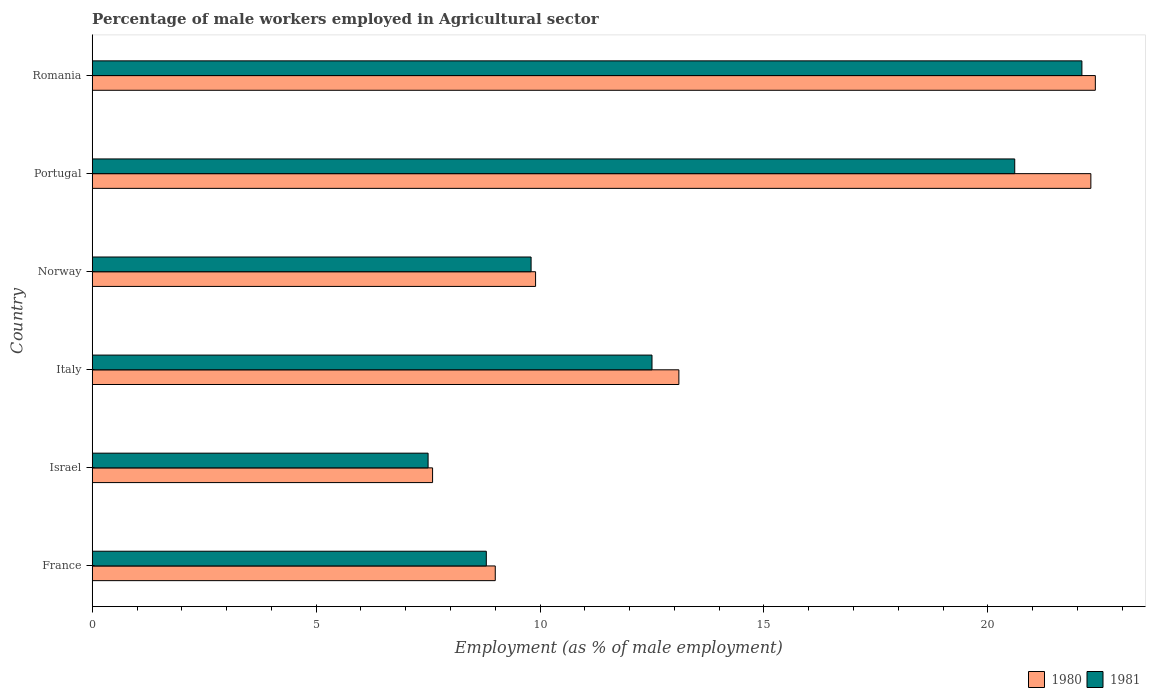In how many cases, is the number of bars for a given country not equal to the number of legend labels?
Make the answer very short. 0. What is the percentage of male workers employed in Agricultural sector in 1980 in Israel?
Provide a succinct answer. 7.6. Across all countries, what is the maximum percentage of male workers employed in Agricultural sector in 1981?
Give a very brief answer. 22.1. Across all countries, what is the minimum percentage of male workers employed in Agricultural sector in 1981?
Make the answer very short. 7.5. In which country was the percentage of male workers employed in Agricultural sector in 1981 maximum?
Provide a short and direct response. Romania. In which country was the percentage of male workers employed in Agricultural sector in 1981 minimum?
Keep it short and to the point. Israel. What is the total percentage of male workers employed in Agricultural sector in 1980 in the graph?
Provide a short and direct response. 84.3. What is the difference between the percentage of male workers employed in Agricultural sector in 1981 in Israel and that in Romania?
Provide a succinct answer. -14.6. What is the difference between the percentage of male workers employed in Agricultural sector in 1981 in Portugal and the percentage of male workers employed in Agricultural sector in 1980 in Romania?
Your answer should be very brief. -1.8. What is the average percentage of male workers employed in Agricultural sector in 1980 per country?
Your response must be concise. 14.05. What is the difference between the percentage of male workers employed in Agricultural sector in 1981 and percentage of male workers employed in Agricultural sector in 1980 in France?
Give a very brief answer. -0.2. In how many countries, is the percentage of male workers employed in Agricultural sector in 1980 greater than 12 %?
Ensure brevity in your answer.  3. What is the ratio of the percentage of male workers employed in Agricultural sector in 1981 in Italy to that in Romania?
Make the answer very short. 0.57. Is the difference between the percentage of male workers employed in Agricultural sector in 1981 in Portugal and Romania greater than the difference between the percentage of male workers employed in Agricultural sector in 1980 in Portugal and Romania?
Provide a short and direct response. No. What is the difference between the highest and the second highest percentage of male workers employed in Agricultural sector in 1981?
Keep it short and to the point. 1.5. What is the difference between the highest and the lowest percentage of male workers employed in Agricultural sector in 1980?
Make the answer very short. 14.8. In how many countries, is the percentage of male workers employed in Agricultural sector in 1980 greater than the average percentage of male workers employed in Agricultural sector in 1980 taken over all countries?
Ensure brevity in your answer.  2. Is the sum of the percentage of male workers employed in Agricultural sector in 1981 in Israel and Norway greater than the maximum percentage of male workers employed in Agricultural sector in 1980 across all countries?
Make the answer very short. No. What does the 1st bar from the top in Portugal represents?
Ensure brevity in your answer.  1981. What does the 2nd bar from the bottom in Romania represents?
Offer a very short reply. 1981. Are the values on the major ticks of X-axis written in scientific E-notation?
Ensure brevity in your answer.  No. What is the title of the graph?
Offer a terse response. Percentage of male workers employed in Agricultural sector. Does "1967" appear as one of the legend labels in the graph?
Make the answer very short. No. What is the label or title of the X-axis?
Offer a terse response. Employment (as % of male employment). What is the label or title of the Y-axis?
Ensure brevity in your answer.  Country. What is the Employment (as % of male employment) of 1980 in France?
Your answer should be very brief. 9. What is the Employment (as % of male employment) in 1981 in France?
Your answer should be very brief. 8.8. What is the Employment (as % of male employment) of 1980 in Israel?
Give a very brief answer. 7.6. What is the Employment (as % of male employment) in 1981 in Israel?
Your answer should be compact. 7.5. What is the Employment (as % of male employment) in 1980 in Italy?
Offer a terse response. 13.1. What is the Employment (as % of male employment) in 1981 in Italy?
Offer a very short reply. 12.5. What is the Employment (as % of male employment) of 1980 in Norway?
Keep it short and to the point. 9.9. What is the Employment (as % of male employment) in 1981 in Norway?
Offer a terse response. 9.8. What is the Employment (as % of male employment) of 1980 in Portugal?
Your answer should be compact. 22.3. What is the Employment (as % of male employment) of 1981 in Portugal?
Your answer should be very brief. 20.6. What is the Employment (as % of male employment) in 1980 in Romania?
Provide a short and direct response. 22.4. What is the Employment (as % of male employment) in 1981 in Romania?
Your response must be concise. 22.1. Across all countries, what is the maximum Employment (as % of male employment) of 1980?
Your answer should be very brief. 22.4. Across all countries, what is the maximum Employment (as % of male employment) of 1981?
Give a very brief answer. 22.1. Across all countries, what is the minimum Employment (as % of male employment) of 1980?
Offer a terse response. 7.6. What is the total Employment (as % of male employment) of 1980 in the graph?
Provide a short and direct response. 84.3. What is the total Employment (as % of male employment) in 1981 in the graph?
Make the answer very short. 81.3. What is the difference between the Employment (as % of male employment) in 1981 in France and that in Israel?
Offer a very short reply. 1.3. What is the difference between the Employment (as % of male employment) in 1981 in France and that in Norway?
Provide a short and direct response. -1. What is the difference between the Employment (as % of male employment) in 1981 in France and that in Portugal?
Your answer should be very brief. -11.8. What is the difference between the Employment (as % of male employment) in 1980 in France and that in Romania?
Provide a succinct answer. -13.4. What is the difference between the Employment (as % of male employment) in 1981 in France and that in Romania?
Provide a succinct answer. -13.3. What is the difference between the Employment (as % of male employment) of 1980 in Israel and that in Italy?
Your answer should be compact. -5.5. What is the difference between the Employment (as % of male employment) in 1980 in Israel and that in Portugal?
Your response must be concise. -14.7. What is the difference between the Employment (as % of male employment) of 1981 in Israel and that in Portugal?
Keep it short and to the point. -13.1. What is the difference between the Employment (as % of male employment) of 1980 in Israel and that in Romania?
Offer a terse response. -14.8. What is the difference between the Employment (as % of male employment) of 1981 in Israel and that in Romania?
Keep it short and to the point. -14.6. What is the difference between the Employment (as % of male employment) in 1980 in Italy and that in Norway?
Provide a succinct answer. 3.2. What is the difference between the Employment (as % of male employment) in 1981 in Italy and that in Norway?
Offer a terse response. 2.7. What is the difference between the Employment (as % of male employment) of 1980 in Italy and that in Portugal?
Give a very brief answer. -9.2. What is the difference between the Employment (as % of male employment) in 1981 in Italy and that in Portugal?
Provide a short and direct response. -8.1. What is the difference between the Employment (as % of male employment) in 1981 in Norway and that in Portugal?
Offer a terse response. -10.8. What is the difference between the Employment (as % of male employment) in 1980 in Norway and that in Romania?
Give a very brief answer. -12.5. What is the difference between the Employment (as % of male employment) in 1980 in Portugal and that in Romania?
Your answer should be compact. -0.1. What is the difference between the Employment (as % of male employment) in 1980 in France and the Employment (as % of male employment) in 1981 in Israel?
Keep it short and to the point. 1.5. What is the difference between the Employment (as % of male employment) in 1980 in France and the Employment (as % of male employment) in 1981 in Italy?
Make the answer very short. -3.5. What is the difference between the Employment (as % of male employment) in 1980 in Italy and the Employment (as % of male employment) in 1981 in Norway?
Your answer should be compact. 3.3. What is the difference between the Employment (as % of male employment) in 1980 in Norway and the Employment (as % of male employment) in 1981 in Portugal?
Offer a terse response. -10.7. What is the difference between the Employment (as % of male employment) of 1980 in Norway and the Employment (as % of male employment) of 1981 in Romania?
Your answer should be very brief. -12.2. What is the difference between the Employment (as % of male employment) of 1980 in Portugal and the Employment (as % of male employment) of 1981 in Romania?
Ensure brevity in your answer.  0.2. What is the average Employment (as % of male employment) in 1980 per country?
Offer a very short reply. 14.05. What is the average Employment (as % of male employment) of 1981 per country?
Make the answer very short. 13.55. What is the difference between the Employment (as % of male employment) of 1980 and Employment (as % of male employment) of 1981 in Israel?
Make the answer very short. 0.1. What is the difference between the Employment (as % of male employment) in 1980 and Employment (as % of male employment) in 1981 in Norway?
Provide a short and direct response. 0.1. What is the difference between the Employment (as % of male employment) of 1980 and Employment (as % of male employment) of 1981 in Portugal?
Provide a succinct answer. 1.7. What is the ratio of the Employment (as % of male employment) of 1980 in France to that in Israel?
Offer a very short reply. 1.18. What is the ratio of the Employment (as % of male employment) in 1981 in France to that in Israel?
Offer a very short reply. 1.17. What is the ratio of the Employment (as % of male employment) in 1980 in France to that in Italy?
Provide a succinct answer. 0.69. What is the ratio of the Employment (as % of male employment) of 1981 in France to that in Italy?
Ensure brevity in your answer.  0.7. What is the ratio of the Employment (as % of male employment) of 1980 in France to that in Norway?
Keep it short and to the point. 0.91. What is the ratio of the Employment (as % of male employment) in 1981 in France to that in Norway?
Provide a short and direct response. 0.9. What is the ratio of the Employment (as % of male employment) of 1980 in France to that in Portugal?
Provide a succinct answer. 0.4. What is the ratio of the Employment (as % of male employment) in 1981 in France to that in Portugal?
Give a very brief answer. 0.43. What is the ratio of the Employment (as % of male employment) of 1980 in France to that in Romania?
Offer a terse response. 0.4. What is the ratio of the Employment (as % of male employment) in 1981 in France to that in Romania?
Your answer should be compact. 0.4. What is the ratio of the Employment (as % of male employment) in 1980 in Israel to that in Italy?
Keep it short and to the point. 0.58. What is the ratio of the Employment (as % of male employment) in 1980 in Israel to that in Norway?
Give a very brief answer. 0.77. What is the ratio of the Employment (as % of male employment) in 1981 in Israel to that in Norway?
Offer a terse response. 0.77. What is the ratio of the Employment (as % of male employment) of 1980 in Israel to that in Portugal?
Your answer should be very brief. 0.34. What is the ratio of the Employment (as % of male employment) in 1981 in Israel to that in Portugal?
Provide a short and direct response. 0.36. What is the ratio of the Employment (as % of male employment) in 1980 in Israel to that in Romania?
Offer a very short reply. 0.34. What is the ratio of the Employment (as % of male employment) in 1981 in Israel to that in Romania?
Keep it short and to the point. 0.34. What is the ratio of the Employment (as % of male employment) of 1980 in Italy to that in Norway?
Your answer should be very brief. 1.32. What is the ratio of the Employment (as % of male employment) in 1981 in Italy to that in Norway?
Provide a succinct answer. 1.28. What is the ratio of the Employment (as % of male employment) in 1980 in Italy to that in Portugal?
Provide a short and direct response. 0.59. What is the ratio of the Employment (as % of male employment) in 1981 in Italy to that in Portugal?
Ensure brevity in your answer.  0.61. What is the ratio of the Employment (as % of male employment) of 1980 in Italy to that in Romania?
Provide a short and direct response. 0.58. What is the ratio of the Employment (as % of male employment) of 1981 in Italy to that in Romania?
Keep it short and to the point. 0.57. What is the ratio of the Employment (as % of male employment) in 1980 in Norway to that in Portugal?
Ensure brevity in your answer.  0.44. What is the ratio of the Employment (as % of male employment) in 1981 in Norway to that in Portugal?
Your answer should be compact. 0.48. What is the ratio of the Employment (as % of male employment) of 1980 in Norway to that in Romania?
Make the answer very short. 0.44. What is the ratio of the Employment (as % of male employment) of 1981 in Norway to that in Romania?
Your answer should be compact. 0.44. What is the ratio of the Employment (as % of male employment) in 1980 in Portugal to that in Romania?
Offer a very short reply. 1. What is the ratio of the Employment (as % of male employment) of 1981 in Portugal to that in Romania?
Your answer should be very brief. 0.93. What is the difference between the highest and the second highest Employment (as % of male employment) of 1980?
Your answer should be very brief. 0.1. What is the difference between the highest and the lowest Employment (as % of male employment) of 1980?
Provide a short and direct response. 14.8. What is the difference between the highest and the lowest Employment (as % of male employment) in 1981?
Your answer should be compact. 14.6. 